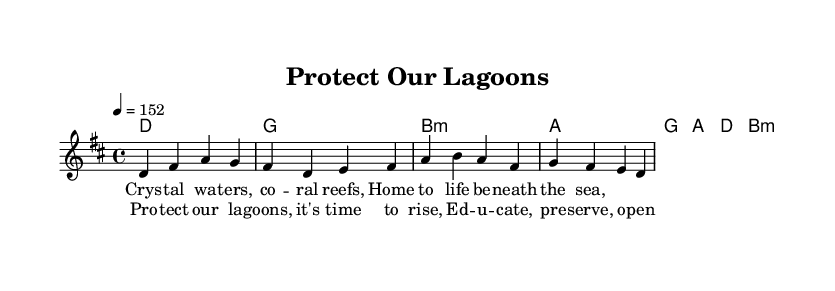What is the key signature of this music? The key signature is D major, which has two sharps (F# and C#).
Answer: D major What is the time signature of this music? The time signature is 4/4, which indicates that there are four beats in each measure and the quarter note gets one beat.
Answer: 4/4 What is the tempo marking of this piece? The tempo is marked as 152 beats per minute, indicating a fast-paced feel typical of punk music.
Answer: 152 How many measures are in the verse? The verse consists of 8 measures, as indicated by the grouping of the musical phrases in the sheet music.
Answer: 8 What is the main theme of the lyrics? The main theme of the lyrics focuses on environmental conservation and the importance of protecting lagoons and coral reefs.
Answer: Environmental conservation What chords are used in the chorus? The chorus uses the chords G, A, D, and B minor, creating a common progression typically found in punk songs.
Answer: G, A, D, B minor What phrase is repeated in the chorus? The phrase "Protect our lagoons" is repeated in the chorus, emphasizing the call to action in the song.
Answer: Protect our lagoons 